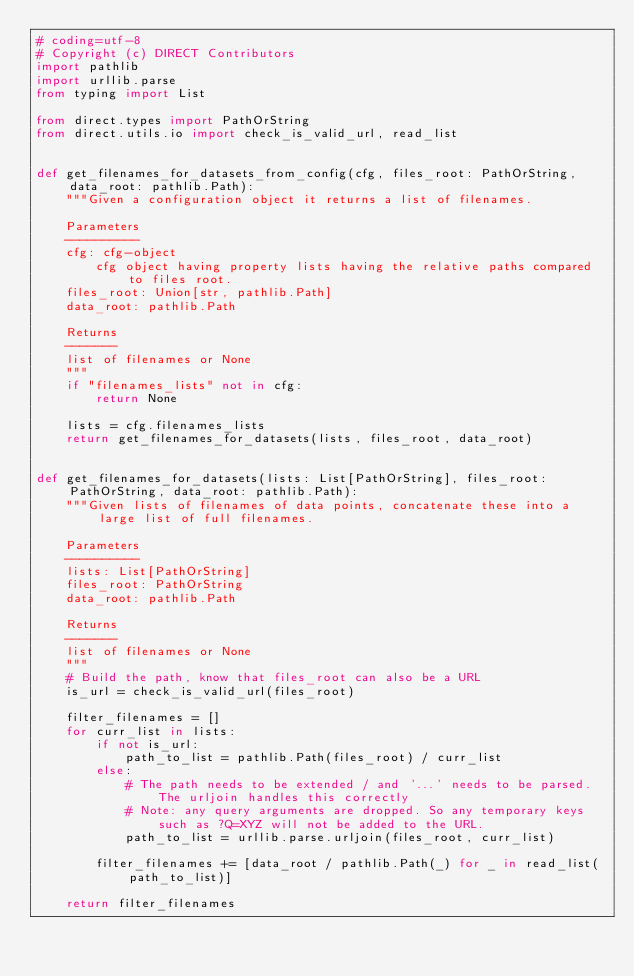<code> <loc_0><loc_0><loc_500><loc_500><_Python_># coding=utf-8
# Copyright (c) DIRECT Contributors
import pathlib
import urllib.parse
from typing import List

from direct.types import PathOrString
from direct.utils.io import check_is_valid_url, read_list


def get_filenames_for_datasets_from_config(cfg, files_root: PathOrString, data_root: pathlib.Path):
    """Given a configuration object it returns a list of filenames.

    Parameters
    ----------
    cfg: cfg-object
        cfg object having property lists having the relative paths compared to files root.
    files_root: Union[str, pathlib.Path]
    data_root: pathlib.Path

    Returns
    -------
    list of filenames or None
    """
    if "filenames_lists" not in cfg:
        return None

    lists = cfg.filenames_lists
    return get_filenames_for_datasets(lists, files_root, data_root)


def get_filenames_for_datasets(lists: List[PathOrString], files_root: PathOrString, data_root: pathlib.Path):
    """Given lists of filenames of data points, concatenate these into a large list of full filenames.

    Parameters
    ----------
    lists: List[PathOrString]
    files_root: PathOrString
    data_root: pathlib.Path

    Returns
    -------
    list of filenames or None
    """
    # Build the path, know that files_root can also be a URL
    is_url = check_is_valid_url(files_root)

    filter_filenames = []
    for curr_list in lists:
        if not is_url:
            path_to_list = pathlib.Path(files_root) / curr_list
        else:
            # The path needs to be extended / and '...' needs to be parsed. The urljoin handles this correctly
            # Note: any query arguments are dropped. So any temporary keys such as ?Q=XYZ will not be added to the URL.
            path_to_list = urllib.parse.urljoin(files_root, curr_list)

        filter_filenames += [data_root / pathlib.Path(_) for _ in read_list(path_to_list)]

    return filter_filenames
</code> 